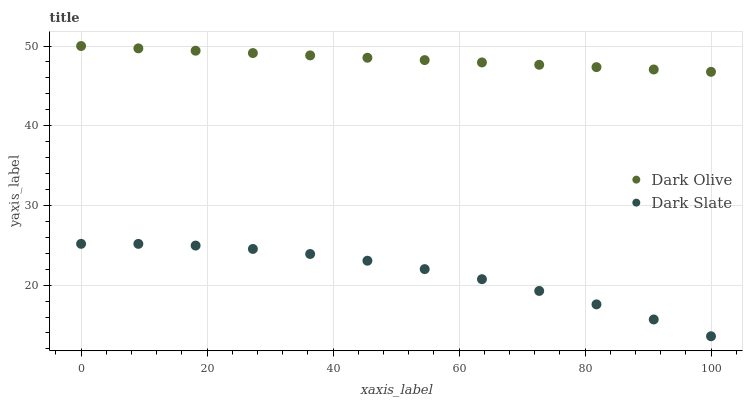Does Dark Slate have the minimum area under the curve?
Answer yes or no. Yes. Does Dark Olive have the maximum area under the curve?
Answer yes or no. Yes. Does Dark Olive have the minimum area under the curve?
Answer yes or no. No. Is Dark Olive the smoothest?
Answer yes or no. Yes. Is Dark Slate the roughest?
Answer yes or no. Yes. Is Dark Olive the roughest?
Answer yes or no. No. Does Dark Slate have the lowest value?
Answer yes or no. Yes. Does Dark Olive have the lowest value?
Answer yes or no. No. Does Dark Olive have the highest value?
Answer yes or no. Yes. Is Dark Slate less than Dark Olive?
Answer yes or no. Yes. Is Dark Olive greater than Dark Slate?
Answer yes or no. Yes. Does Dark Slate intersect Dark Olive?
Answer yes or no. No. 